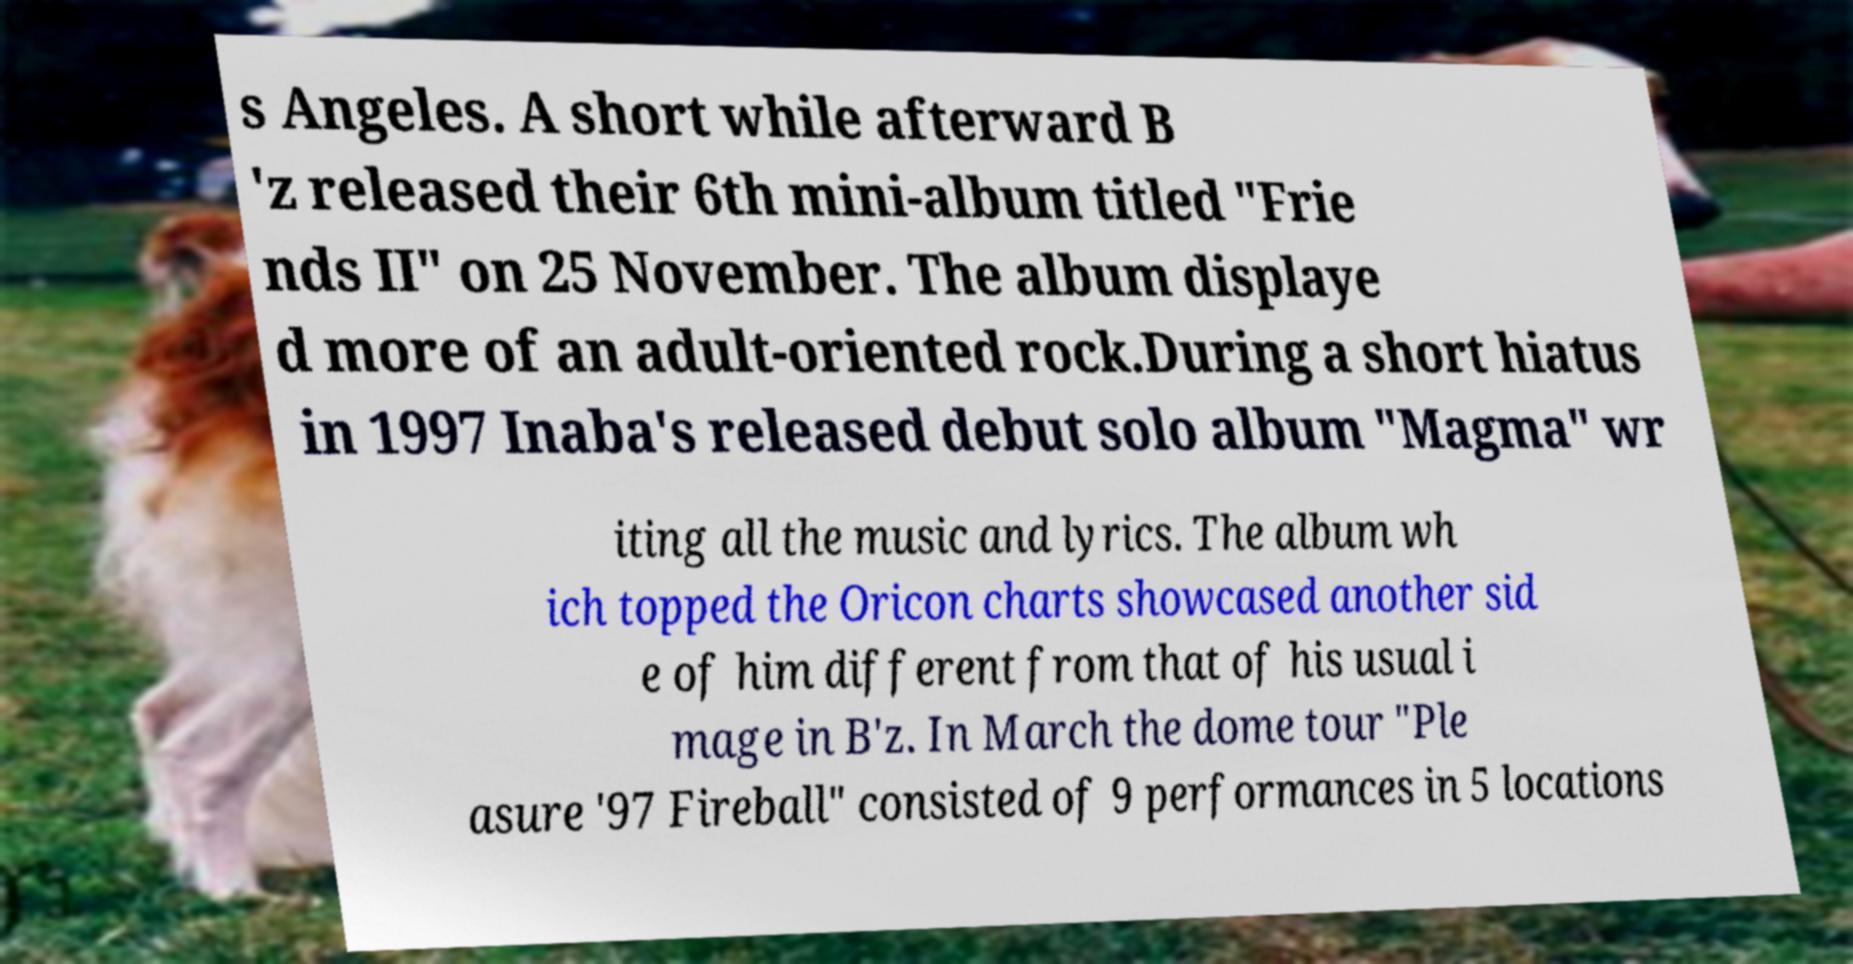Please identify and transcribe the text found in this image. s Angeles. A short while afterward B 'z released their 6th mini-album titled "Frie nds II" on 25 November. The album displaye d more of an adult-oriented rock.During a short hiatus in 1997 Inaba's released debut solo album "Magma" wr iting all the music and lyrics. The album wh ich topped the Oricon charts showcased another sid e of him different from that of his usual i mage in B'z. In March the dome tour "Ple asure '97 Fireball" consisted of 9 performances in 5 locations 